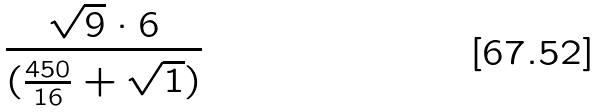<formula> <loc_0><loc_0><loc_500><loc_500>\frac { \sqrt { 9 } \cdot 6 } { ( \frac { 4 5 0 } { 1 6 } + \sqrt { 1 } ) }</formula> 